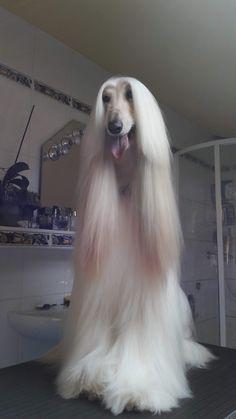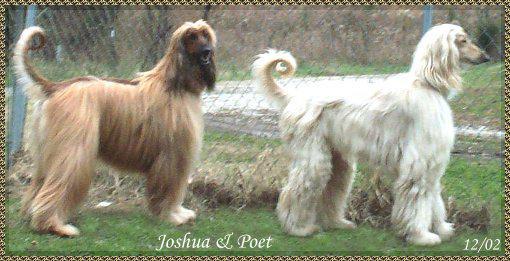The first image is the image on the left, the second image is the image on the right. Examine the images to the left and right. Is the description "At least one of the dogs is standing up outside in the grass." accurate? Answer yes or no. Yes. The first image is the image on the left, the second image is the image on the right. Examine the images to the left and right. Is the description "At least one afghan hound with a curled upright tail is standing in profile." accurate? Answer yes or no. Yes. 